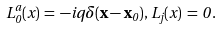<formula> <loc_0><loc_0><loc_500><loc_500>L ^ { a } _ { 0 } ( x ) \, = \, - i q \delta ( { \mathbf x } - { \mathbf x } _ { 0 } ) , \, L _ { j } ( x ) \, = \, 0 \, .</formula> 